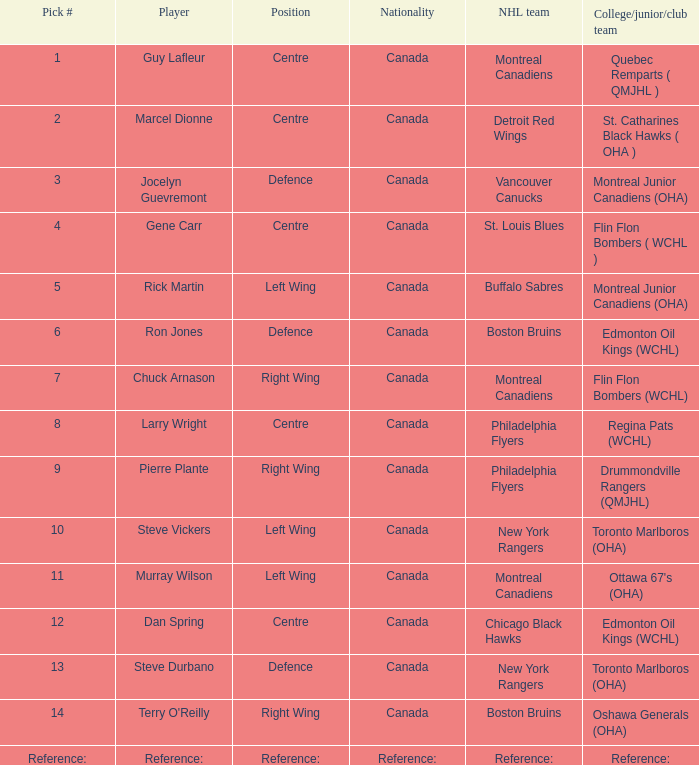Which Pick # has an NHL team of detroit red wings? 2.0. 